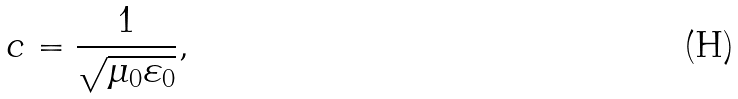<formula> <loc_0><loc_0><loc_500><loc_500>c = \frac { 1 } { \sqrt { \mu _ { 0 } \varepsilon _ { 0 } } } ,</formula> 